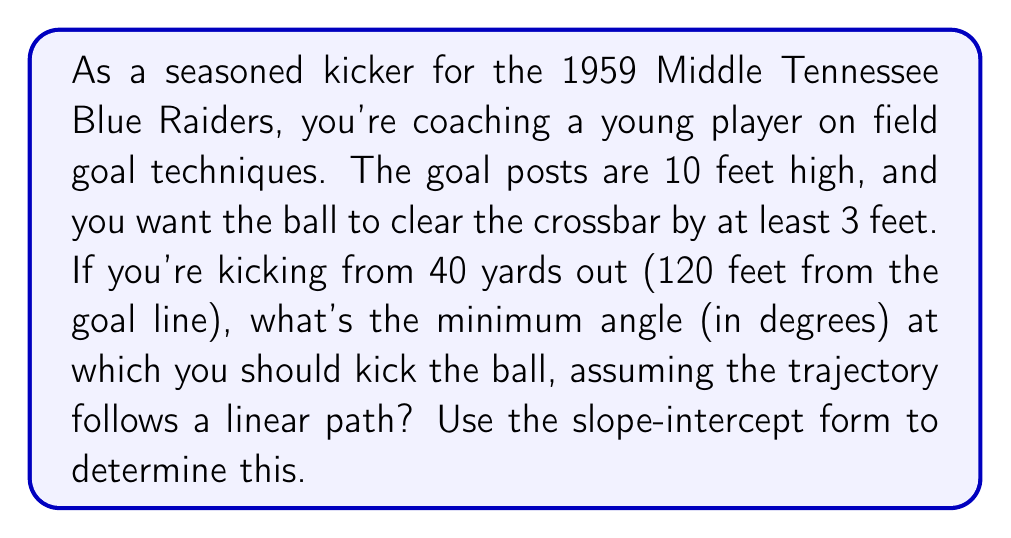Could you help me with this problem? Let's approach this step-by-step:

1) First, we need to set up our coordinate system. Let's make the goal line the y-axis and the ground the x-axis. The point where we're kicking from is (120, 0), and we want the ball to clear (0, 13) - that's 10 feet for the goal post height plus 3 feet clearance.

2) We can use the slope-intercept form of a line: $y = mx + b$

3) We need to find the slope $m$. The slope represents the minimum angle we're looking for. It's the rise over the run:

   $m = \frac{y_2 - y_1}{x_2 - x_1} = \frac{13 - 0}{0 - 120} = -\frac{13}{120}$

4) Now we have: $y = -\frac{13}{120}x + b$

5) We can find $b$ by plugging in the point (120, 0):

   $0 = -\frac{13}{120}(120) + b$
   $0 = -13 + b$
   $b = 13$

6) So our line equation is: $y = -\frac{13}{120}x + 13$

7) The slope $-\frac{13}{120}$ gives us the tangent of the angle we're looking for. To find the angle, we need to use the arctangent function:

   $\theta = \arctan(\frac{13}{120})$

8) Converting to degrees:

   $\theta = \arctan(\frac{13}{120}) \cdot \frac{180}{\pi} \approx 6.18°$
Answer: $6.18°$ 